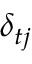Convert formula to latex. <formula><loc_0><loc_0><loc_500><loc_500>\delta _ { t j }</formula> 